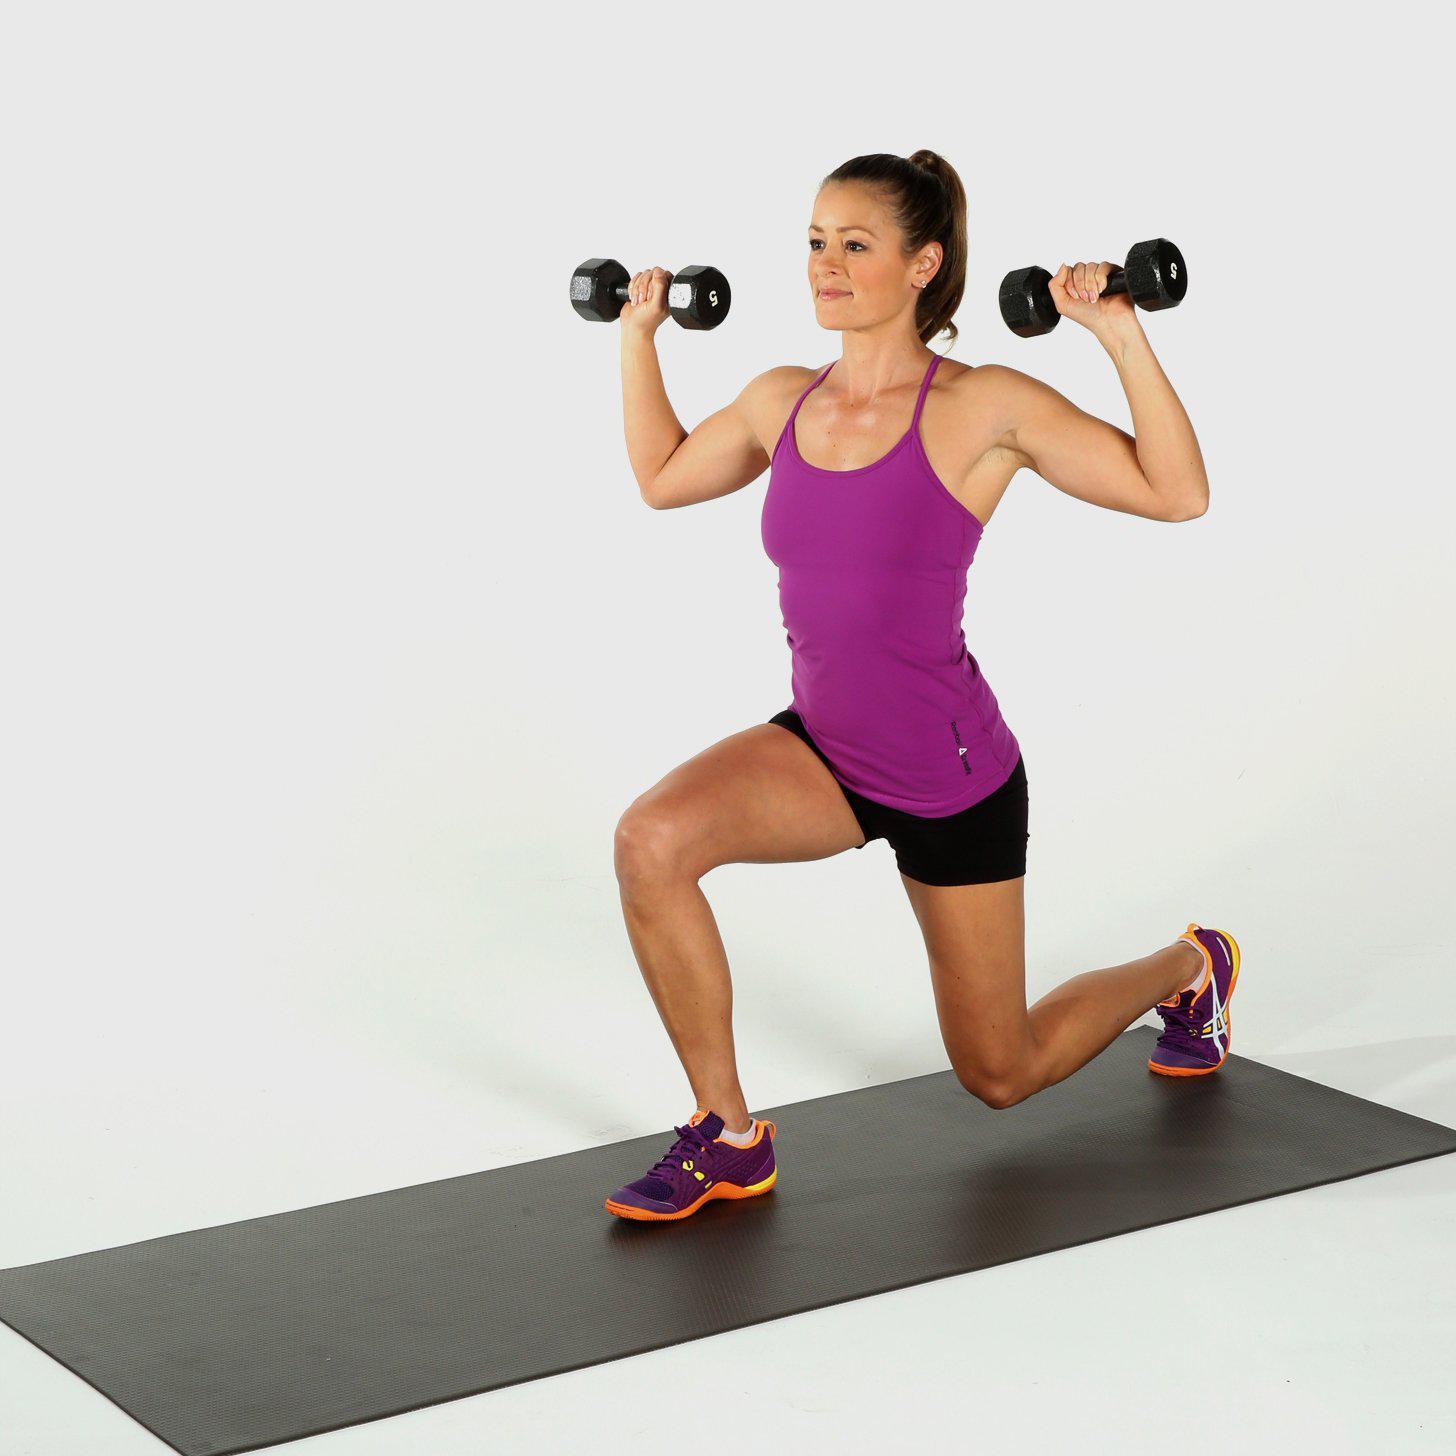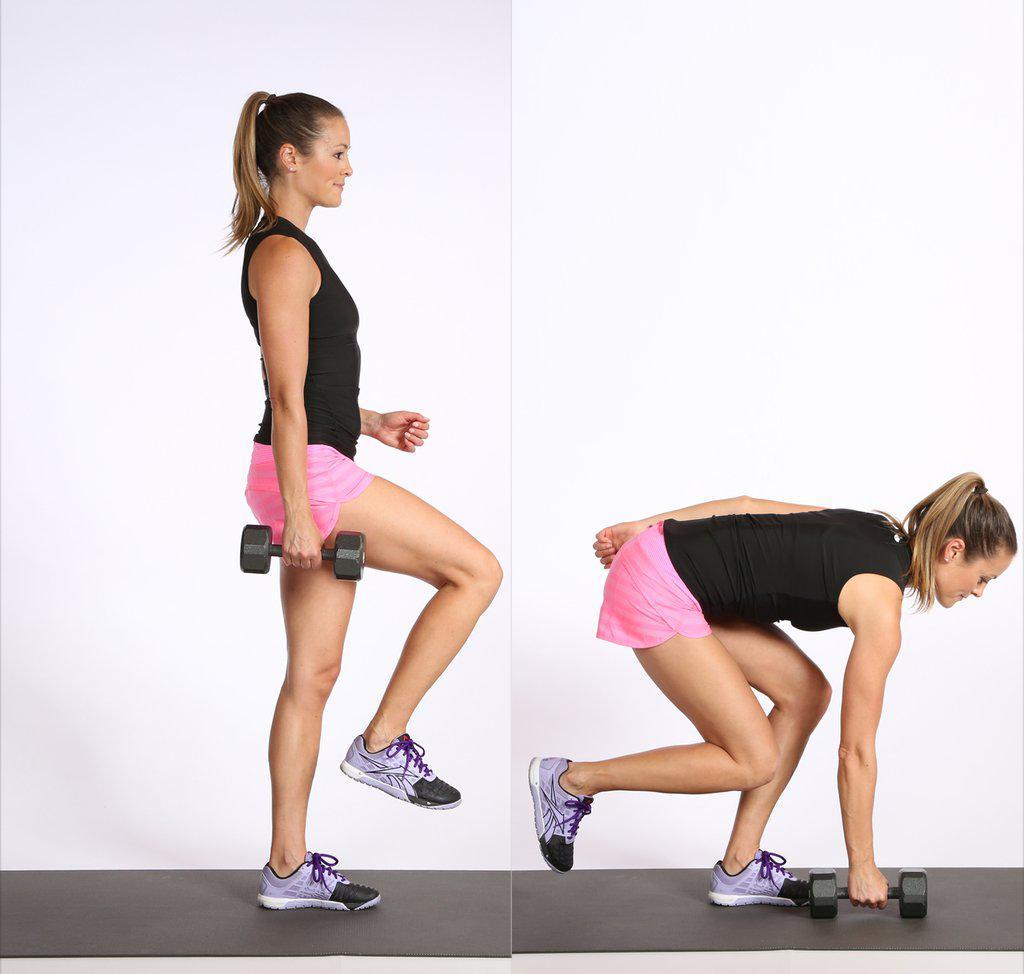The first image is the image on the left, the second image is the image on the right. Assess this claim about the two images: "One of the images contains a woman sitting on fitness equipment.". Correct or not? Answer yes or no. No. The first image is the image on the left, the second image is the image on the right. Assess this claim about the two images: "There is both a man and a woman demonstrating weight lifting techniques.". Correct or not? Answer yes or no. No. 